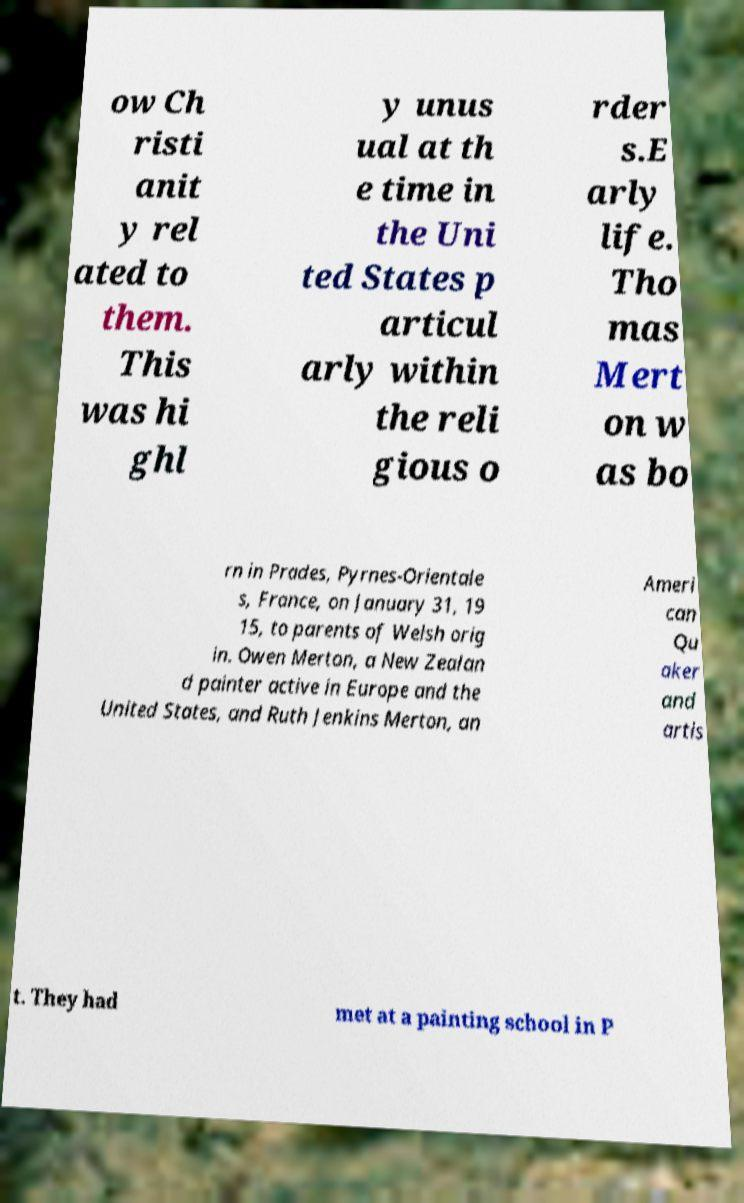Can you read and provide the text displayed in the image?This photo seems to have some interesting text. Can you extract and type it out for me? ow Ch risti anit y rel ated to them. This was hi ghl y unus ual at th e time in the Uni ted States p articul arly within the reli gious o rder s.E arly life. Tho mas Mert on w as bo rn in Prades, Pyrnes-Orientale s, France, on January 31, 19 15, to parents of Welsh orig in. Owen Merton, a New Zealan d painter active in Europe and the United States, and Ruth Jenkins Merton, an Ameri can Qu aker and artis t. They had met at a painting school in P 